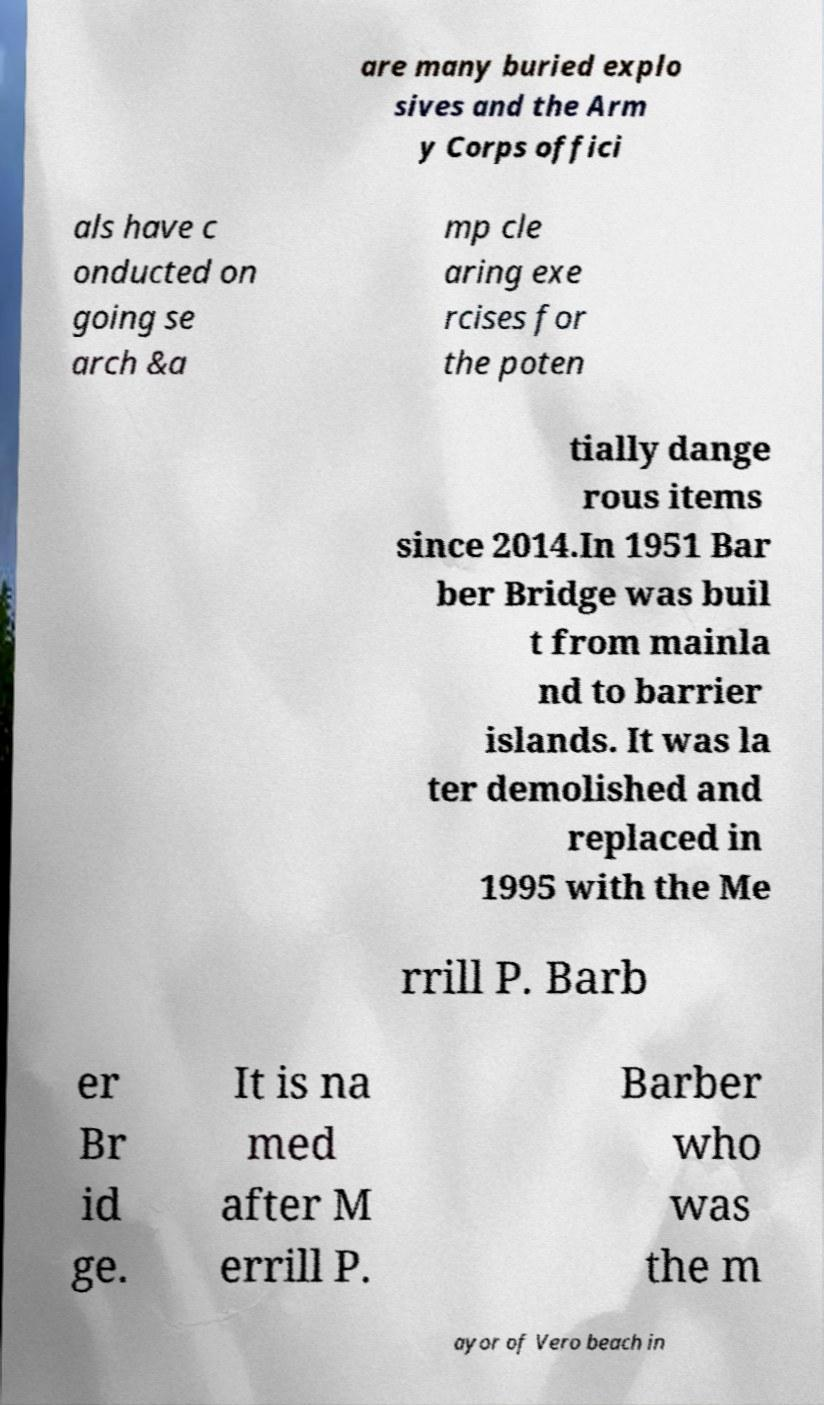Please read and relay the text visible in this image. What does it say? are many buried explo sives and the Arm y Corps offici als have c onducted on going se arch &a mp cle aring exe rcises for the poten tially dange rous items since 2014.In 1951 Bar ber Bridge was buil t from mainla nd to barrier islands. It was la ter demolished and replaced in 1995 with the Me rrill P. Barb er Br id ge. It is na med after M errill P. Barber who was the m ayor of Vero beach in 